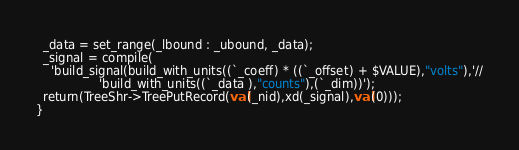<code> <loc_0><loc_0><loc_500><loc_500><_SML_>  _data = set_range(_lbound : _ubound, _data);
  _signal = compile(
    'build_signal(build_with_units((`_coeff) * ((`_offset) + $VALUE),"volts"),'//
                 'build_with_units((`_data ),"counts"),(`_dim))');
  return(TreeShr->TreePutRecord(val(_nid),xd(_signal),val(0)));
}
</code> 